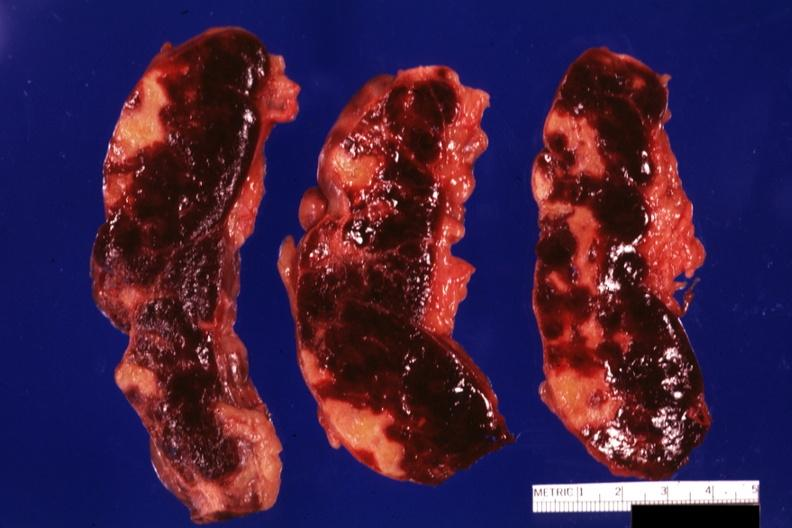s endometritis postpartum present?
Answer the question using a single word or phrase. No 